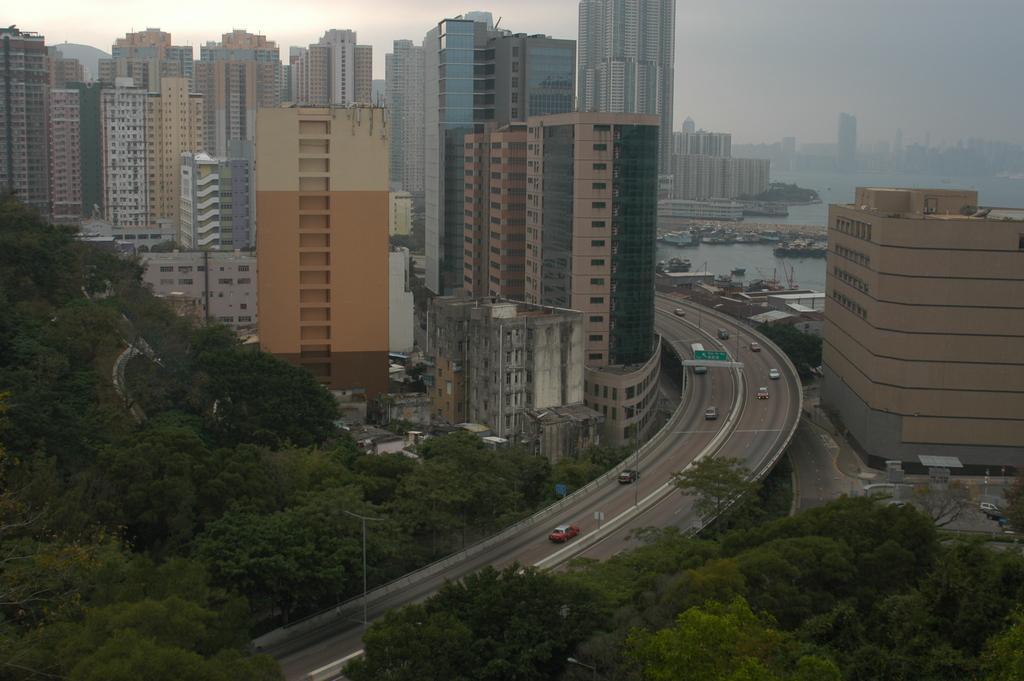Could you give a brief overview of what you see in this image? This is an aerial view, in this image there are trees, bridge, on that bridge there are vehicles moving on either side of the bridge there are buildings and there is a river. 